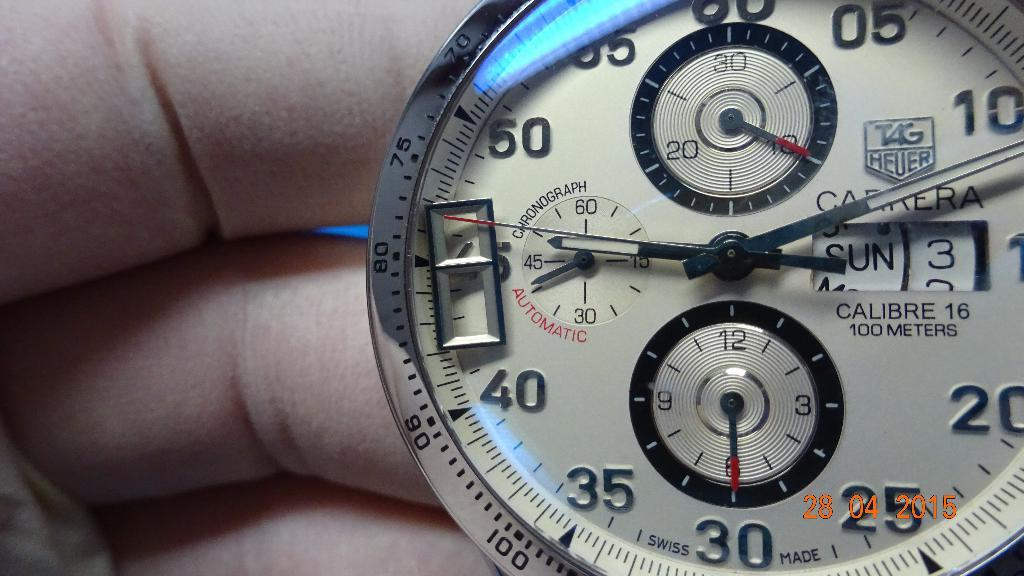<image>
Describe the image concisely. a clock with numbers on it and one that reads 40 